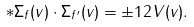<formula> <loc_0><loc_0><loc_500><loc_500>* \Sigma _ { f } ( v ) \cdot \Sigma _ { f ^ { \prime } } ( v ) = \pm 1 2 V ( v ) .</formula> 